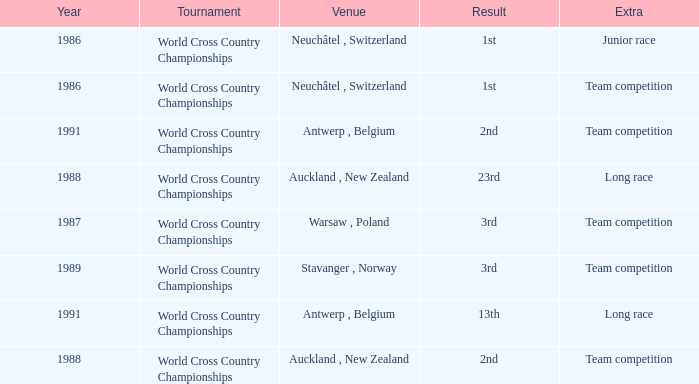Which venue led to a result of 13th and had an extra of Long Race? Antwerp , Belgium. 